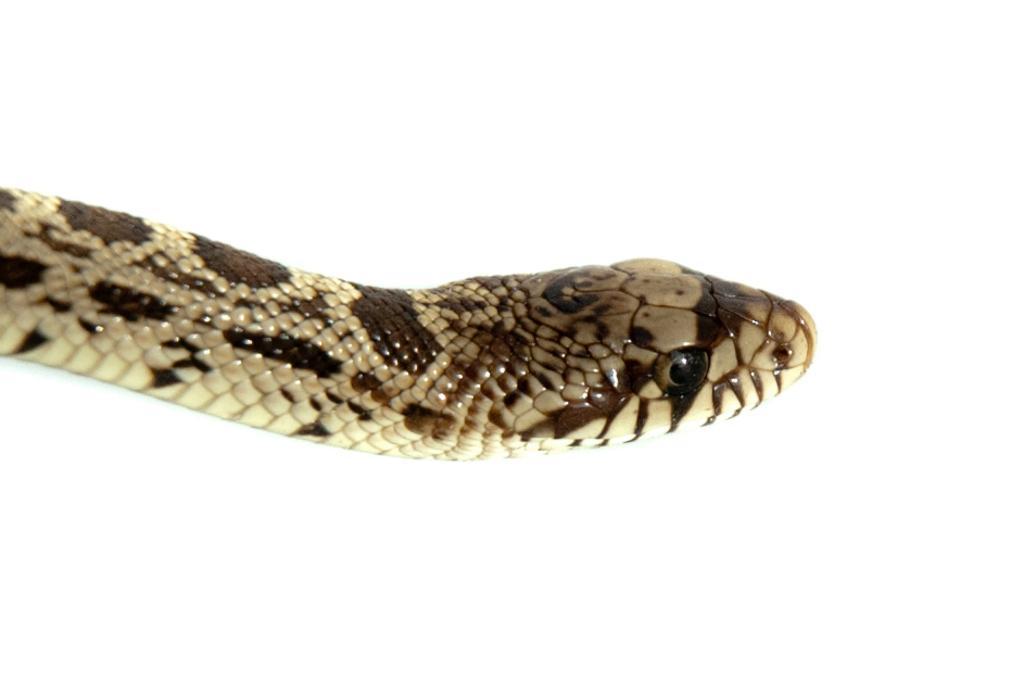In one or two sentences, can you explain what this image depicts? In the center of this picture we can see a snake. The background of the image is white in color. 